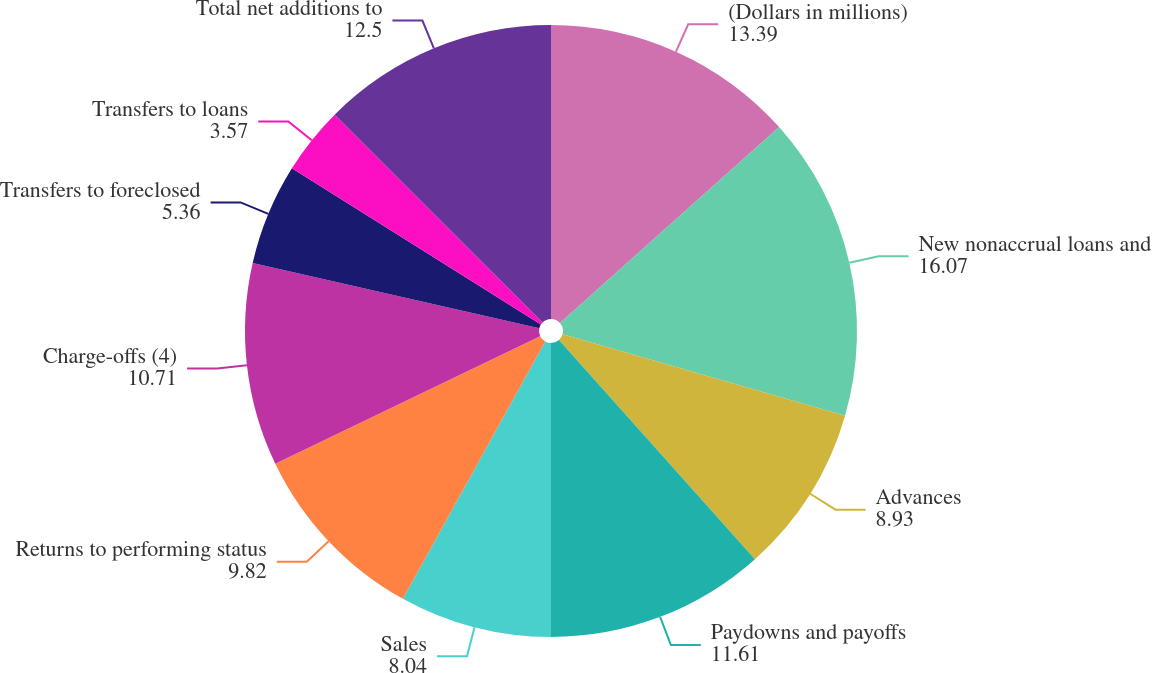Convert chart to OTSL. <chart><loc_0><loc_0><loc_500><loc_500><pie_chart><fcel>(Dollars in millions)<fcel>New nonaccrual loans and<fcel>Advances<fcel>Paydowns and payoffs<fcel>Sales<fcel>Returns to performing status<fcel>Charge-offs (4)<fcel>Transfers to foreclosed<fcel>Transfers to loans<fcel>Total net additions to<nl><fcel>13.39%<fcel>16.07%<fcel>8.93%<fcel>11.61%<fcel>8.04%<fcel>9.82%<fcel>10.71%<fcel>5.36%<fcel>3.57%<fcel>12.5%<nl></chart> 